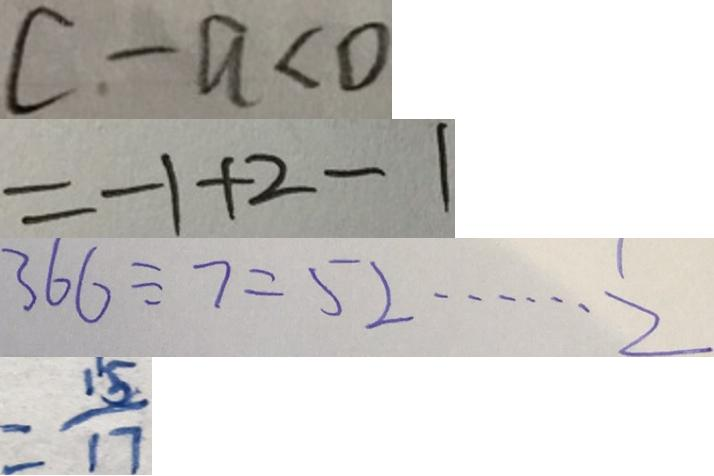Convert formula to latex. <formula><loc_0><loc_0><loc_500><loc_500>c - a < 0 
 = - 1 + 2 - 1 
 3 6 6 \div 7 = 5 2 \cdots 2 
 = \frac { 1 5 } { 1 7 }</formula> 